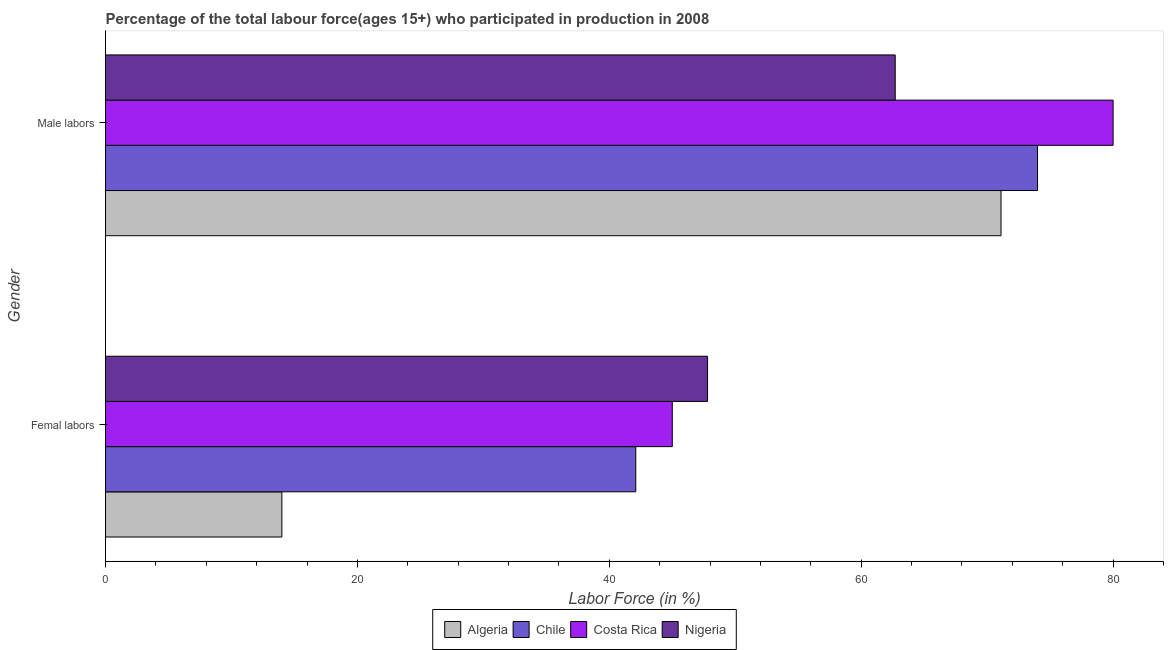Are the number of bars per tick equal to the number of legend labels?
Give a very brief answer. Yes. Are the number of bars on each tick of the Y-axis equal?
Keep it short and to the point. Yes. How many bars are there on the 2nd tick from the bottom?
Keep it short and to the point. 4. What is the label of the 2nd group of bars from the top?
Ensure brevity in your answer.  Femal labors. What is the percentage of female labor force in Nigeria?
Your answer should be very brief. 47.8. Across all countries, what is the maximum percentage of female labor force?
Your answer should be compact. 47.8. In which country was the percentage of female labor force maximum?
Your answer should be compact. Nigeria. In which country was the percentage of male labour force minimum?
Your response must be concise. Nigeria. What is the total percentage of female labor force in the graph?
Give a very brief answer. 148.9. What is the difference between the percentage of male labour force in Costa Rica and that in Nigeria?
Provide a short and direct response. 17.3. What is the difference between the percentage of female labor force in Nigeria and the percentage of male labour force in Algeria?
Provide a succinct answer. -23.3. What is the average percentage of female labor force per country?
Your response must be concise. 37.22. What is the difference between the percentage of male labour force and percentage of female labor force in Chile?
Provide a succinct answer. 31.9. In how many countries, is the percentage of male labour force greater than 28 %?
Your answer should be compact. 4. What is the ratio of the percentage of female labor force in Costa Rica to that in Nigeria?
Keep it short and to the point. 0.94. What does the 1st bar from the bottom in Male labors represents?
Your response must be concise. Algeria. Are all the bars in the graph horizontal?
Provide a succinct answer. Yes. How many countries are there in the graph?
Offer a very short reply. 4. What is the difference between two consecutive major ticks on the X-axis?
Offer a very short reply. 20. Are the values on the major ticks of X-axis written in scientific E-notation?
Your response must be concise. No. Does the graph contain grids?
Keep it short and to the point. No. What is the title of the graph?
Provide a short and direct response. Percentage of the total labour force(ages 15+) who participated in production in 2008. Does "East Asia (developing only)" appear as one of the legend labels in the graph?
Ensure brevity in your answer.  No. What is the label or title of the X-axis?
Your response must be concise. Labor Force (in %). What is the label or title of the Y-axis?
Give a very brief answer. Gender. What is the Labor Force (in %) of Chile in Femal labors?
Offer a terse response. 42.1. What is the Labor Force (in %) of Nigeria in Femal labors?
Ensure brevity in your answer.  47.8. What is the Labor Force (in %) of Algeria in Male labors?
Your answer should be very brief. 71.1. What is the Labor Force (in %) of Chile in Male labors?
Your answer should be compact. 74. What is the Labor Force (in %) in Nigeria in Male labors?
Offer a very short reply. 62.7. Across all Gender, what is the maximum Labor Force (in %) of Algeria?
Your response must be concise. 71.1. Across all Gender, what is the maximum Labor Force (in %) of Costa Rica?
Give a very brief answer. 80. Across all Gender, what is the maximum Labor Force (in %) of Nigeria?
Your answer should be very brief. 62.7. Across all Gender, what is the minimum Labor Force (in %) of Chile?
Provide a succinct answer. 42.1. Across all Gender, what is the minimum Labor Force (in %) in Nigeria?
Provide a succinct answer. 47.8. What is the total Labor Force (in %) in Algeria in the graph?
Ensure brevity in your answer.  85.1. What is the total Labor Force (in %) of Chile in the graph?
Make the answer very short. 116.1. What is the total Labor Force (in %) of Costa Rica in the graph?
Give a very brief answer. 125. What is the total Labor Force (in %) in Nigeria in the graph?
Your answer should be compact. 110.5. What is the difference between the Labor Force (in %) of Algeria in Femal labors and that in Male labors?
Provide a short and direct response. -57.1. What is the difference between the Labor Force (in %) of Chile in Femal labors and that in Male labors?
Offer a very short reply. -31.9. What is the difference between the Labor Force (in %) in Costa Rica in Femal labors and that in Male labors?
Make the answer very short. -35. What is the difference between the Labor Force (in %) in Nigeria in Femal labors and that in Male labors?
Your answer should be compact. -14.9. What is the difference between the Labor Force (in %) of Algeria in Femal labors and the Labor Force (in %) of Chile in Male labors?
Give a very brief answer. -60. What is the difference between the Labor Force (in %) in Algeria in Femal labors and the Labor Force (in %) in Costa Rica in Male labors?
Make the answer very short. -66. What is the difference between the Labor Force (in %) in Algeria in Femal labors and the Labor Force (in %) in Nigeria in Male labors?
Give a very brief answer. -48.7. What is the difference between the Labor Force (in %) of Chile in Femal labors and the Labor Force (in %) of Costa Rica in Male labors?
Your response must be concise. -37.9. What is the difference between the Labor Force (in %) of Chile in Femal labors and the Labor Force (in %) of Nigeria in Male labors?
Give a very brief answer. -20.6. What is the difference between the Labor Force (in %) in Costa Rica in Femal labors and the Labor Force (in %) in Nigeria in Male labors?
Provide a short and direct response. -17.7. What is the average Labor Force (in %) of Algeria per Gender?
Offer a very short reply. 42.55. What is the average Labor Force (in %) in Chile per Gender?
Provide a succinct answer. 58.05. What is the average Labor Force (in %) of Costa Rica per Gender?
Offer a very short reply. 62.5. What is the average Labor Force (in %) of Nigeria per Gender?
Keep it short and to the point. 55.25. What is the difference between the Labor Force (in %) in Algeria and Labor Force (in %) in Chile in Femal labors?
Keep it short and to the point. -28.1. What is the difference between the Labor Force (in %) of Algeria and Labor Force (in %) of Costa Rica in Femal labors?
Your answer should be very brief. -31. What is the difference between the Labor Force (in %) in Algeria and Labor Force (in %) in Nigeria in Femal labors?
Ensure brevity in your answer.  -33.8. What is the difference between the Labor Force (in %) in Costa Rica and Labor Force (in %) in Nigeria in Femal labors?
Provide a succinct answer. -2.8. What is the difference between the Labor Force (in %) of Algeria and Labor Force (in %) of Chile in Male labors?
Offer a very short reply. -2.9. What is the difference between the Labor Force (in %) in Algeria and Labor Force (in %) in Costa Rica in Male labors?
Your answer should be very brief. -8.9. What is the difference between the Labor Force (in %) of Algeria and Labor Force (in %) of Nigeria in Male labors?
Give a very brief answer. 8.4. What is the difference between the Labor Force (in %) in Chile and Labor Force (in %) in Nigeria in Male labors?
Your answer should be compact. 11.3. What is the difference between the Labor Force (in %) of Costa Rica and Labor Force (in %) of Nigeria in Male labors?
Ensure brevity in your answer.  17.3. What is the ratio of the Labor Force (in %) of Algeria in Femal labors to that in Male labors?
Provide a succinct answer. 0.2. What is the ratio of the Labor Force (in %) of Chile in Femal labors to that in Male labors?
Ensure brevity in your answer.  0.57. What is the ratio of the Labor Force (in %) of Costa Rica in Femal labors to that in Male labors?
Keep it short and to the point. 0.56. What is the ratio of the Labor Force (in %) in Nigeria in Femal labors to that in Male labors?
Keep it short and to the point. 0.76. What is the difference between the highest and the second highest Labor Force (in %) in Algeria?
Provide a succinct answer. 57.1. What is the difference between the highest and the second highest Labor Force (in %) in Chile?
Your answer should be very brief. 31.9. What is the difference between the highest and the second highest Labor Force (in %) of Costa Rica?
Your answer should be compact. 35. What is the difference between the highest and the second highest Labor Force (in %) in Nigeria?
Provide a short and direct response. 14.9. What is the difference between the highest and the lowest Labor Force (in %) of Algeria?
Provide a short and direct response. 57.1. What is the difference between the highest and the lowest Labor Force (in %) of Chile?
Your answer should be compact. 31.9. What is the difference between the highest and the lowest Labor Force (in %) of Costa Rica?
Provide a succinct answer. 35. 